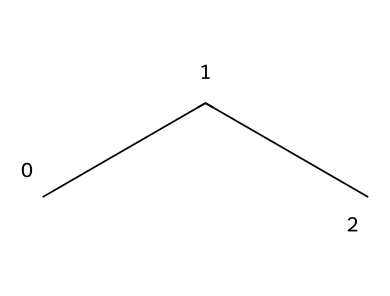What is the molecular formula of propane? The SMILES representation "CCC" indicates that propane consists of three carbon atoms (C) and eight hydrogen atoms (H), which gives the molecular formula C3H8.
Answer: C3H8 How many carbon atoms are present in propane? In the SMILES notation "CCC", each "C" represents a carbon atom, and there are three occurrences of "C". Therefore, there are three carbon atoms.
Answer: 3 Is propane a hydrocarbon? Propane consists solely of carbon (C) and hydrogen (H) atoms, making it a hydrocarbon, which is defined as a compound only composed of these two elements.
Answer: Yes What type of bonds are present in propane? The structure of propane features single bonds between each carbon and hydrogen atom as well as between carbon atoms. This is characteristic of aliphatic hydrocarbons.
Answer: Single bonds What is the environmental impact of using propane as a refrigerant? Propane (R-290) has a low global warming potential (GWP) compared to many traditional refrigerants, making it an environmentally friendly option due to its low impact on the ozone layer and climate.
Answer: Low global warming potential What allows propane to act as an effective refrigerant? Propane has favorable thermodynamic properties, such as efficient heat absorption and release during phase changes, which allows it to efficiently cool applications like refrigerators and air conditioners.
Answer: Efficient heat transfer How does propane compare to HFCs in terms of flammability? Propane is flammable, while many hydrofluorocarbons (HFCs) are not; however, the trade-off for using HFCs is their higher environmental impact, while propane remains flammable.
Answer: Flammable 